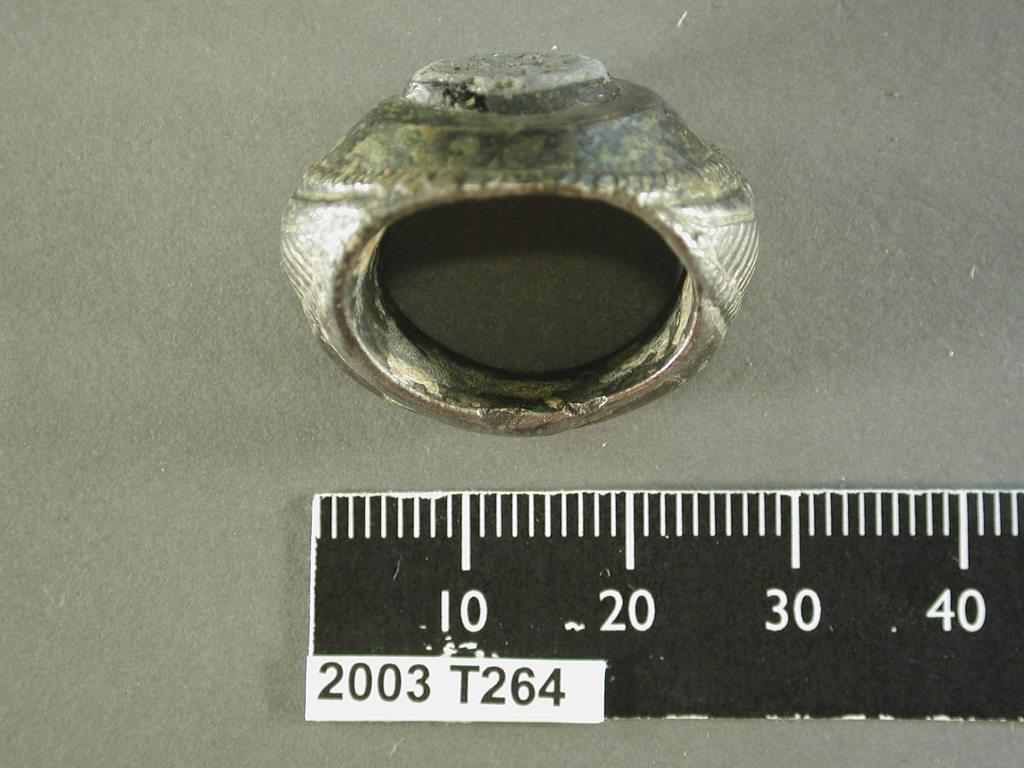<image>
Share a concise interpretation of the image provided. A 2003 T264 ruler measures a ring shaped object. 